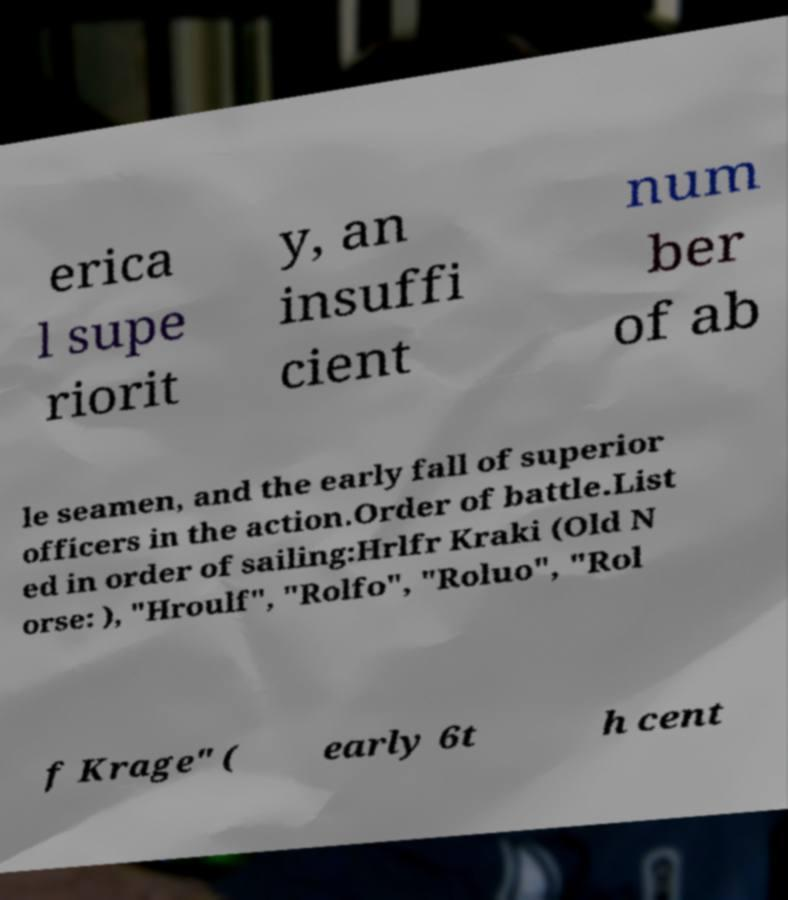For documentation purposes, I need the text within this image transcribed. Could you provide that? erica l supe riorit y, an insuffi cient num ber of ab le seamen, and the early fall of superior officers in the action.Order of battle.List ed in order of sailing:Hrlfr Kraki (Old N orse: ), "Hroulf", "Rolfo", "Roluo", "Rol f Krage" ( early 6t h cent 